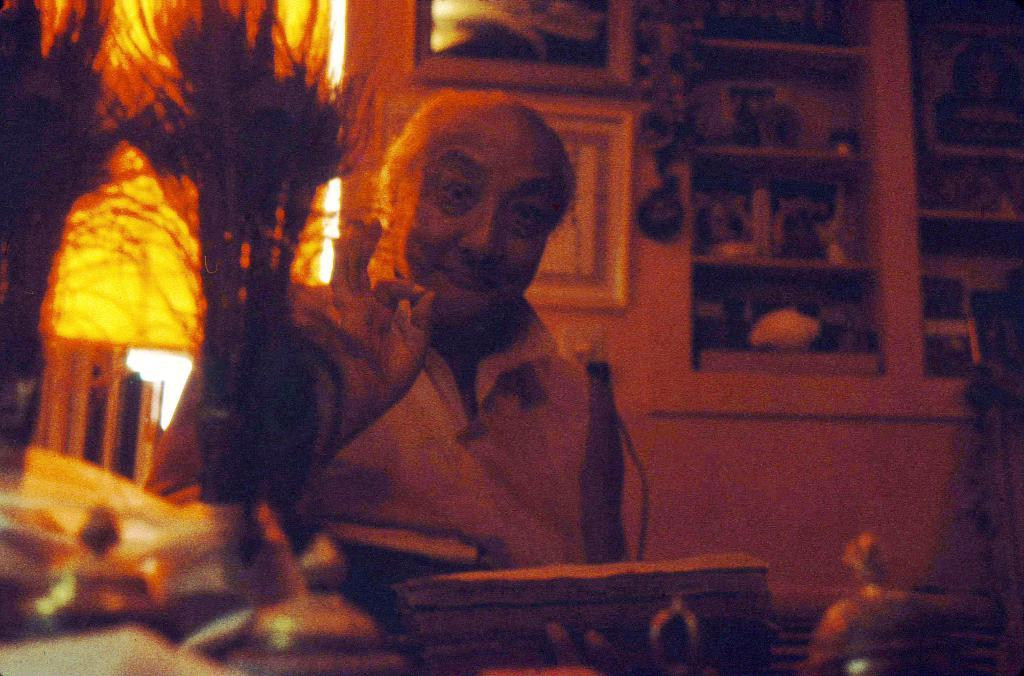Who or what is present in the image? There is a person in the image. What can be observed about the person's attire? The person is wearing clothes. What is the person holding in his hand? The person is holding an object in his hand. What can be seen on the wall in the image? There are photo frames on the wall. What type of furniture is visible in the top right of the image? There is a cupboard in the top right of the image. Can you describe the snail crawling on the range in the image? There is no snail or range present in the image. What type of bushes can be seen in the image? There are no bushes visible in the image. 